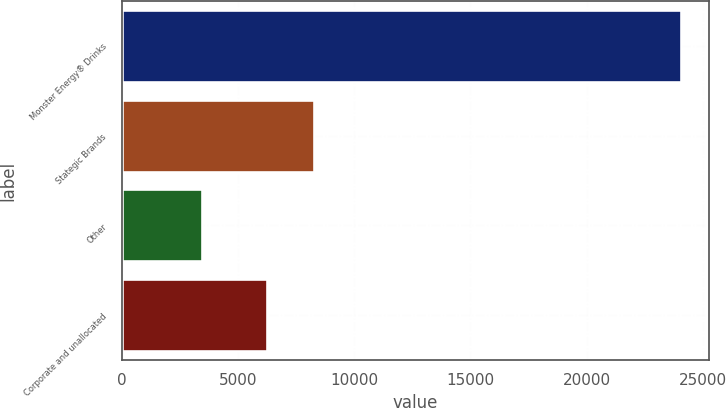Convert chart. <chart><loc_0><loc_0><loc_500><loc_500><bar_chart><fcel>Monster Energy® Drinks<fcel>Stategic Brands<fcel>Other<fcel>Corporate and unallocated<nl><fcel>24048<fcel>8286.1<fcel>3457<fcel>6227<nl></chart> 